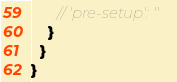<code> <loc_0><loc_0><loc_500><loc_500><_JavaScript_>      // 'pre-setup': ''
    }
  }
}
</code> 